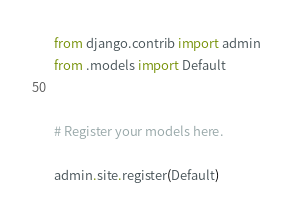<code> <loc_0><loc_0><loc_500><loc_500><_Python_>from django.contrib import admin
from .models import Default


# Register your models here.

admin.site.register(Default)</code> 